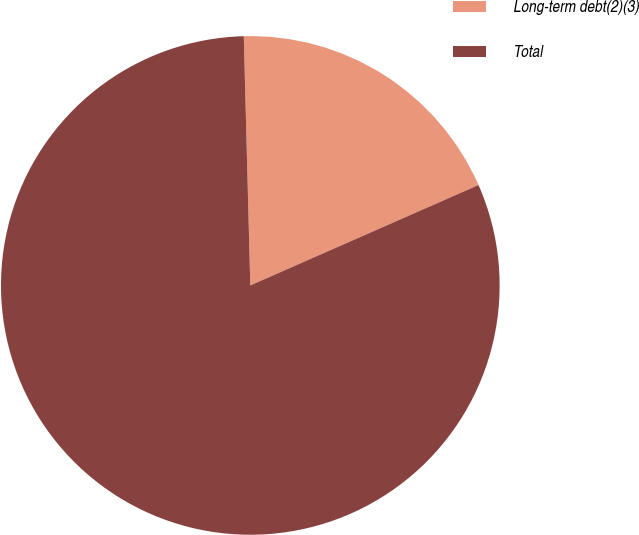<chart> <loc_0><loc_0><loc_500><loc_500><pie_chart><fcel>Long-term debt(2)(3)<fcel>Total<nl><fcel>18.82%<fcel>81.18%<nl></chart> 